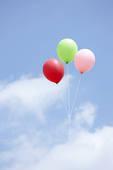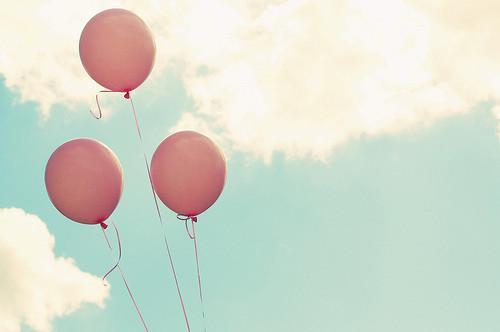The first image is the image on the left, the second image is the image on the right. Assess this claim about the two images: "Three balloons the same color and attached to strings are in one image, while a second image shows three balloons of different colors.". Correct or not? Answer yes or no. Yes. 